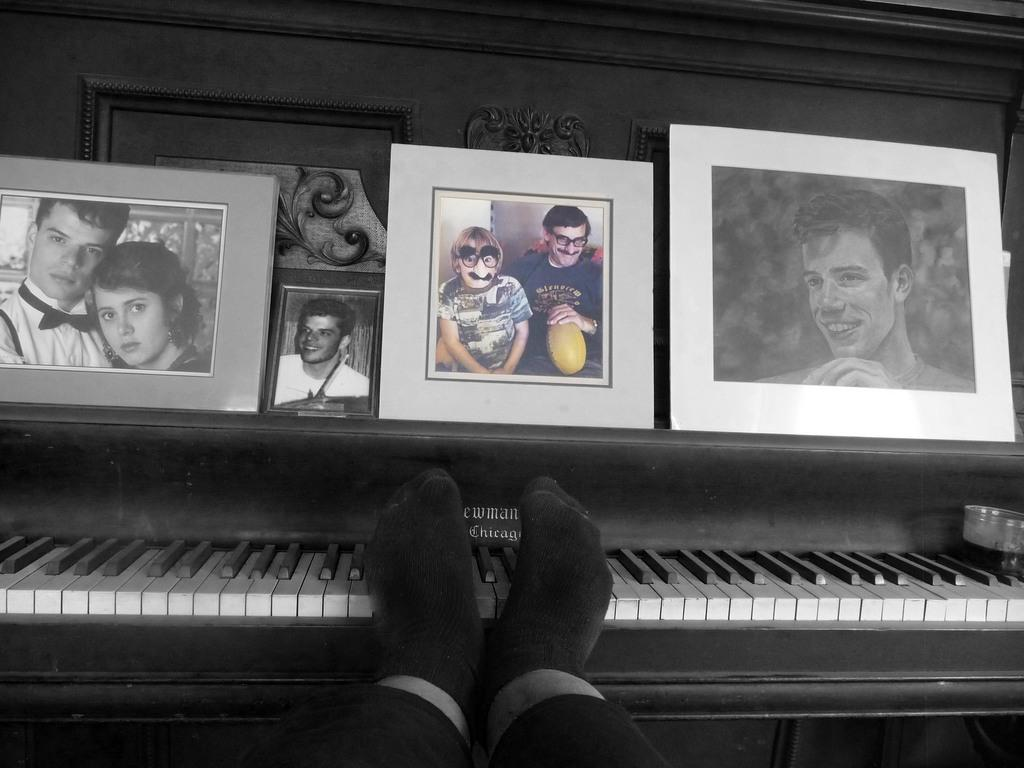What is the person in the image holding? The person is holding a smartphone. What is the person doing with the smartphone? The person is taking a selfie. Is there any other object or feature in the room? Yes, there is a mirror in the room. How many trucks can be seen in the image? There are no trucks present in the image. What type of bear is sitting on the couch with the person? There is no bear present in the image; only a person is visible. 